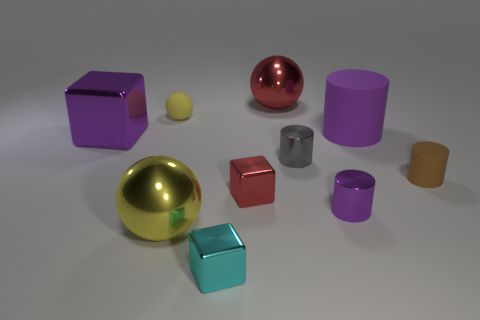How many purple cylinders must be subtracted to get 1 purple cylinders? 1 Subtract all small cylinders. How many cylinders are left? 1 Subtract all red cylinders. How many yellow spheres are left? 2 Subtract all brown cylinders. How many cylinders are left? 3 Subtract 1 spheres. How many spheres are left? 2 Subtract all cylinders. How many objects are left? 6 Add 9 cyan rubber blocks. How many cyan rubber blocks exist? 9 Subtract 0 green cylinders. How many objects are left? 10 Subtract all gray balls. Subtract all red blocks. How many balls are left? 3 Subtract all yellow things. Subtract all big blocks. How many objects are left? 7 